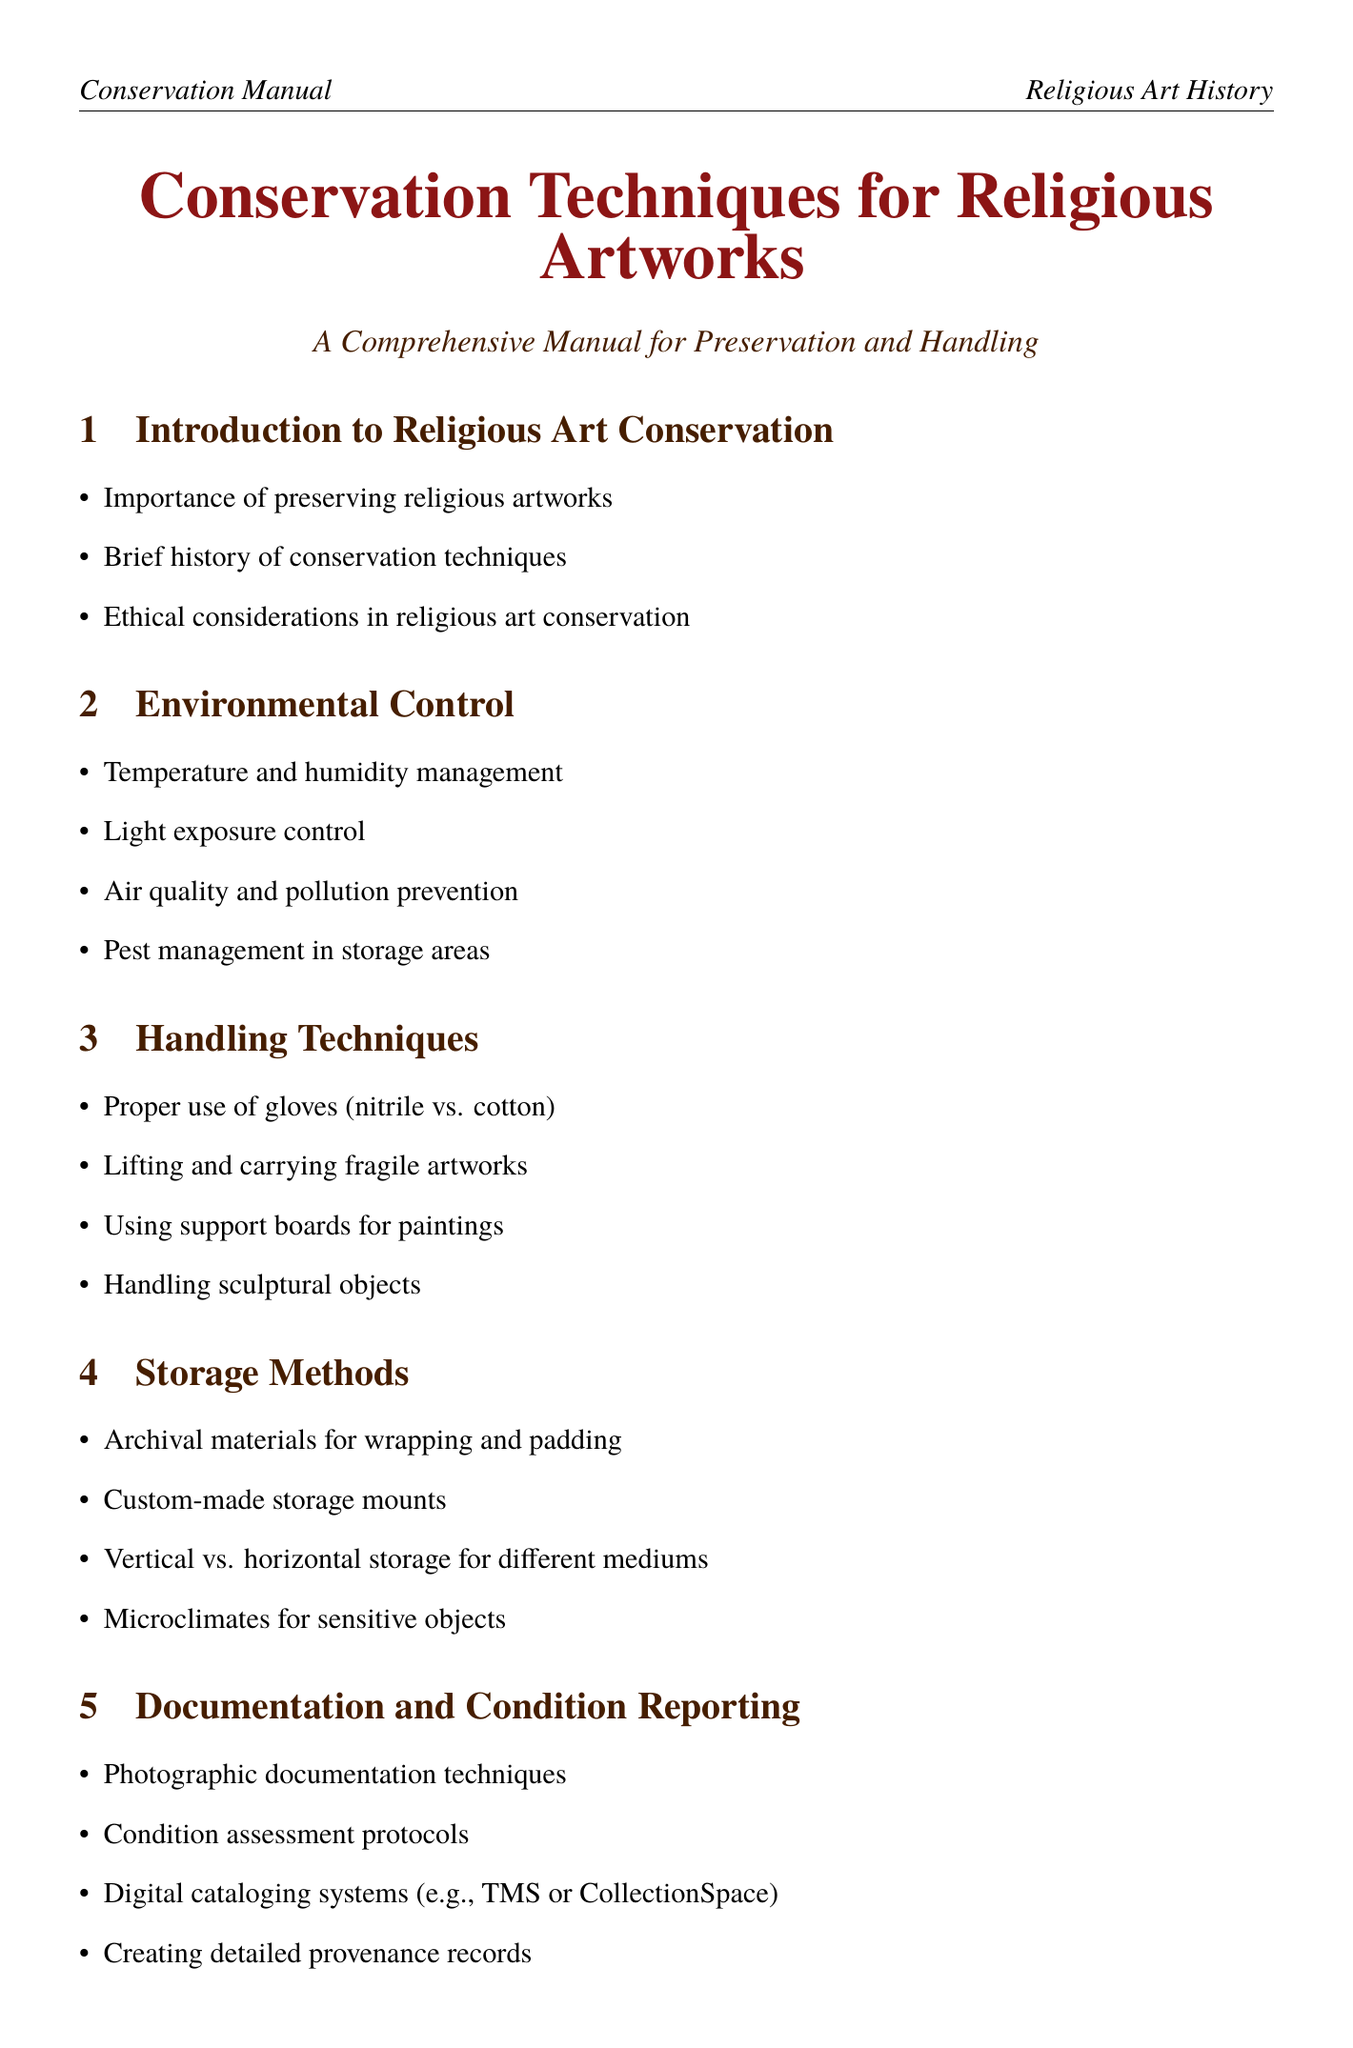What is the first section of the manual? The first section introduces the importance, history, and ethics of religious art conservation.
Answer: Introduction to Religious Art Conservation What type of gloves is recommended for handling artworks? The manual discusses proper glove types to use, specifically nitrile and cotton gloves.
Answer: Nitrile vs. cotton Which technique is used for analyzing varnish? The document lists advanced imaging techniques and specifies UV fluorescence's purpose.
Answer: UV fluorescence What is the focus of the case study on the Ajanta Cave paintings? The case studies section highlights various preservation efforts, including those for the Ajanta Cave paintings.
Answer: Preservation efforts for the Ajanta Cave paintings in India When should one consult a professional conservator? The manual outlines specific scenarios for when it is necessary to seek professional help.
Answer: When to consult a professional conservator How often should inspections be conducted according to preventive conservation? The preventive conservation techniques advocate for regular inspections to maintain the condition of artworks.
Answer: Regular inspection schedules What is a critical aspect of respecting religious sensitivities in conservation? The manual emphasizes the importance of consulting with religious authorities during conservation efforts.
Answer: Consulting with religious authorities on treatment decisions What type of materials are suggested for wrapping and padding? The storage methods discuss archival materials suitable for protecting artworks.
Answer: Archival materials for wrapping and padding 